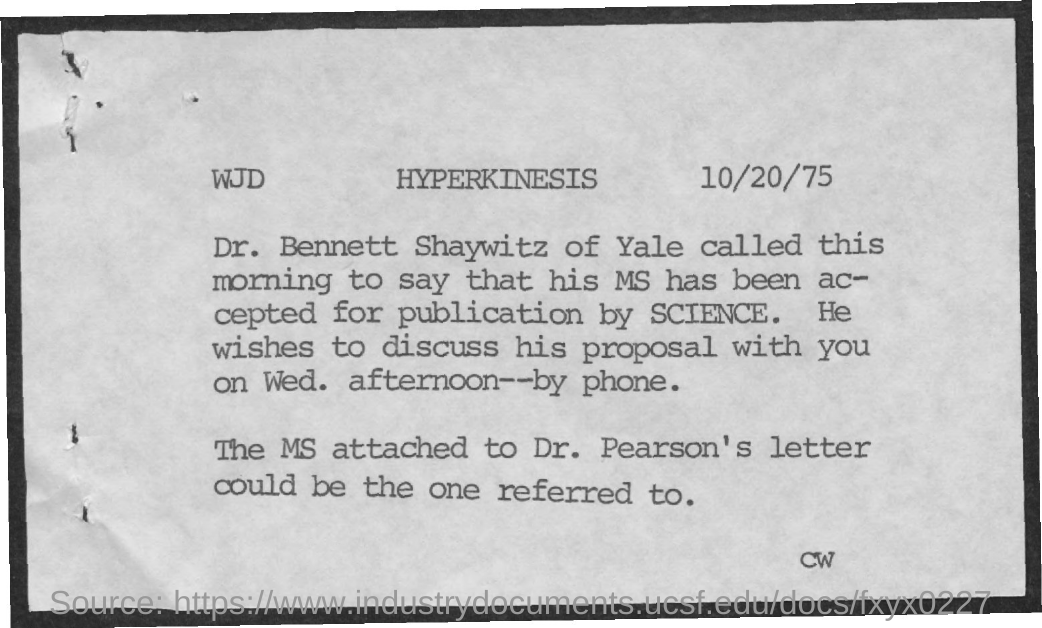What is the Title of the document?
Offer a terse response. Hyperkinesis. What is the date on the document?
Your answer should be compact. 10/20/75. 